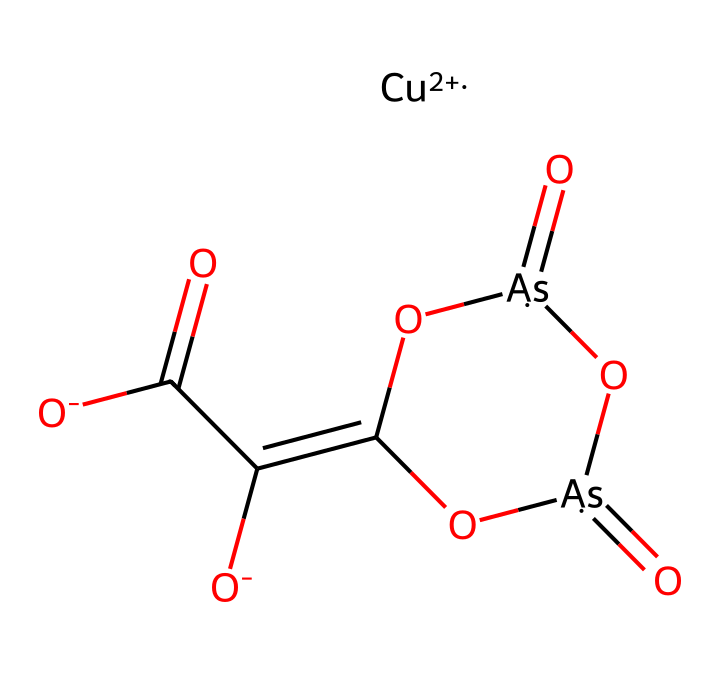What is the main metal in Paris green? The molecular structure includes a copper ion, depicted as [Cu+2], indicating that copper is the primary metal in the compound.
Answer: copper How many arsenic atoms are present in the structure? Upon examining the structure, we see two instances of [As], which means there are two arsenic atoms in the molecular formula.
Answer: two What functional group is represented by the sequence "C(=O)C([O-])"? The presence of the carbonyl group "C(=O)" combined with the hydroxyl "C([O-])" indicates that this section of the molecule represents a carboxylate functional group.
Answer: carboxylate What is the oxidation state of the copper in Paris green? The copper is represented by [Cu+2], which indicates that its oxidation state is +2 in this molecular structure.
Answer: +2 How many total oxygen atoms are there in the structure? By counting the number of oxygen atoms in the structure, there are five "O" occurrences, which gives the total as five oxygen atoms in Paris green.
Answer: five What type of pesticide is Paris green categorized under? Paris green is known as an arsenic-based insecticide specifically, aligning its classification under inorganic pesticides due to its heavy metal components and toxic properties.
Answer: inorganic pesticide What type of compound is characterized by the presence of arsenic? The presence of arsenic in Paris green classifies it as an arsenical compound, which is a specific kind of pesticide used historically for its toxicity to insects.
Answer: arsenical compound 